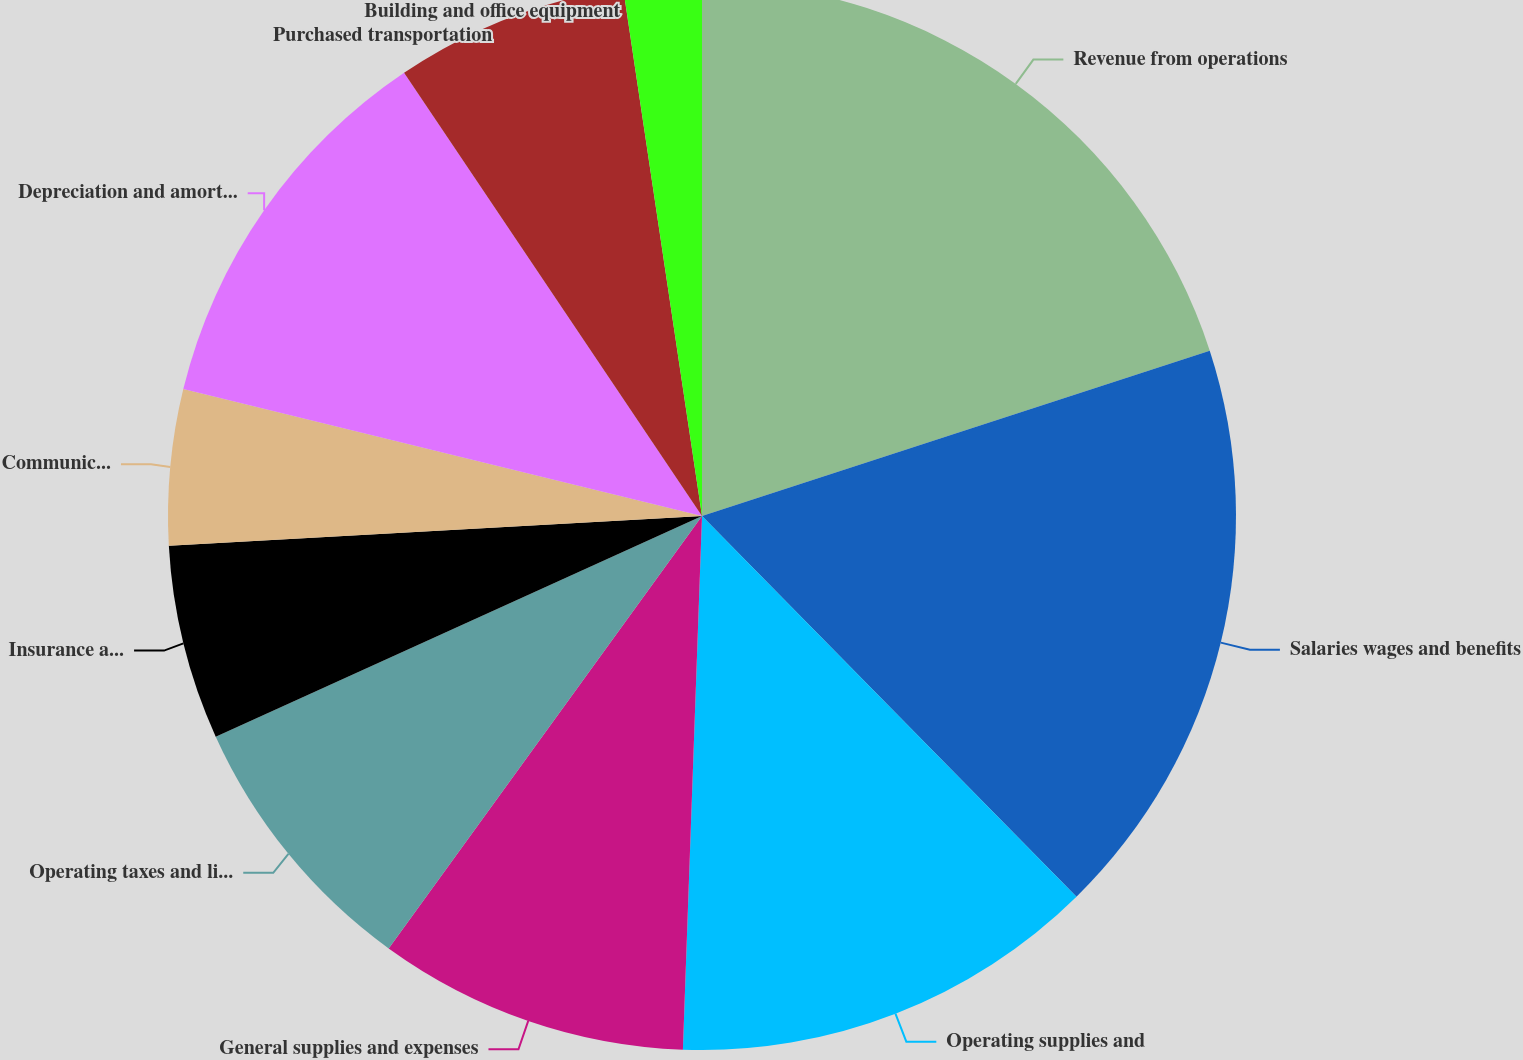Convert chart. <chart><loc_0><loc_0><loc_500><loc_500><pie_chart><fcel>Revenue from operations<fcel>Salaries wages and benefits<fcel>Operating supplies and<fcel>General supplies and expenses<fcel>Operating taxes and licenses<fcel>Insurance and claims<fcel>Communication and utilities<fcel>Depreciation and amortization<fcel>Purchased transportation<fcel>Building and office equipment<nl><fcel>19.99%<fcel>17.64%<fcel>12.94%<fcel>9.41%<fcel>8.24%<fcel>5.89%<fcel>4.71%<fcel>11.76%<fcel>7.06%<fcel>2.36%<nl></chart> 